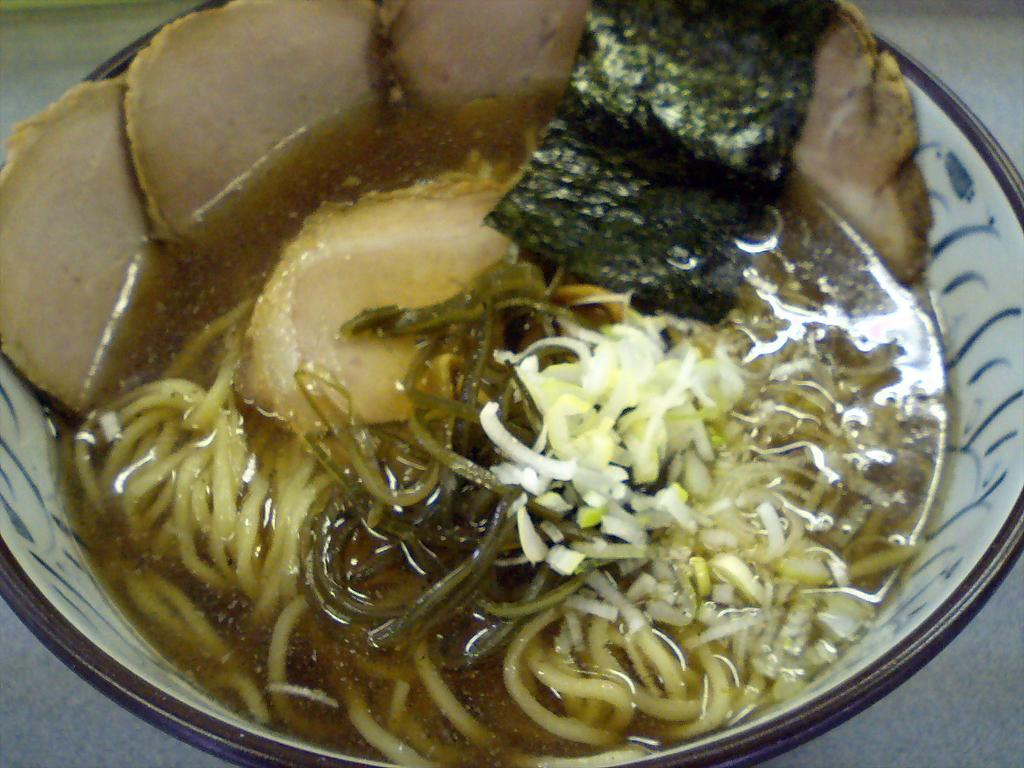What is present in the image? There is a bowl in the image. What is inside the bowl? The bowl contains food items. What type of stocking is visible in the image? There is no stocking present in the image. What is the rate of the food items in the bowl? The rate of the food items in the bowl cannot be determined from the image. 